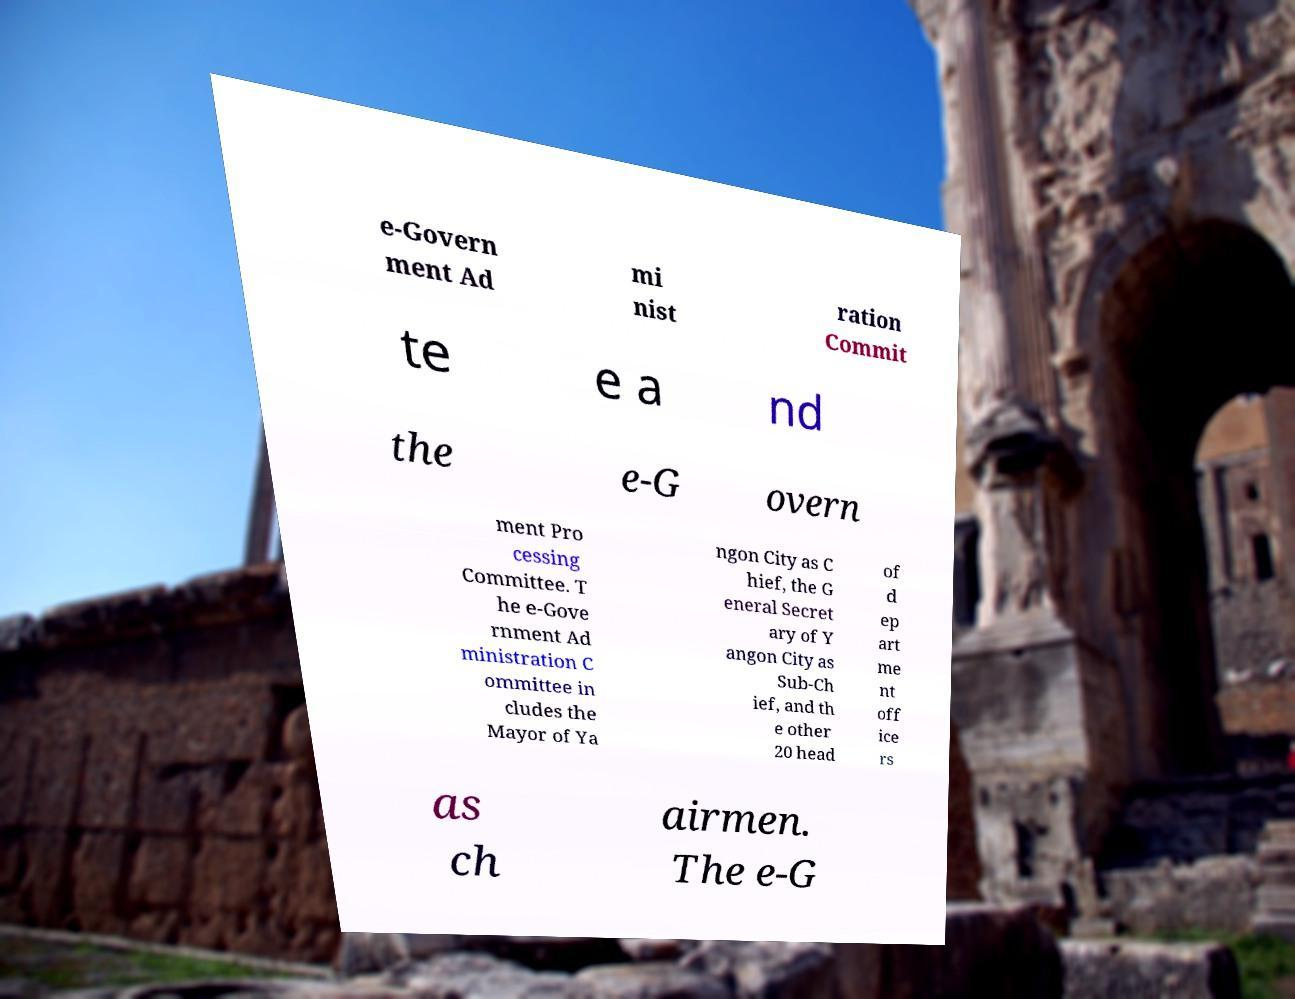Could you assist in decoding the text presented in this image and type it out clearly? e-Govern ment Ad mi nist ration Commit te e a nd the e-G overn ment Pro cessing Committee. T he e-Gove rnment Ad ministration C ommittee in cludes the Mayor of Ya ngon City as C hief, the G eneral Secret ary of Y angon City as Sub-Ch ief, and th e other 20 head of d ep art me nt off ice rs as ch airmen. The e-G 